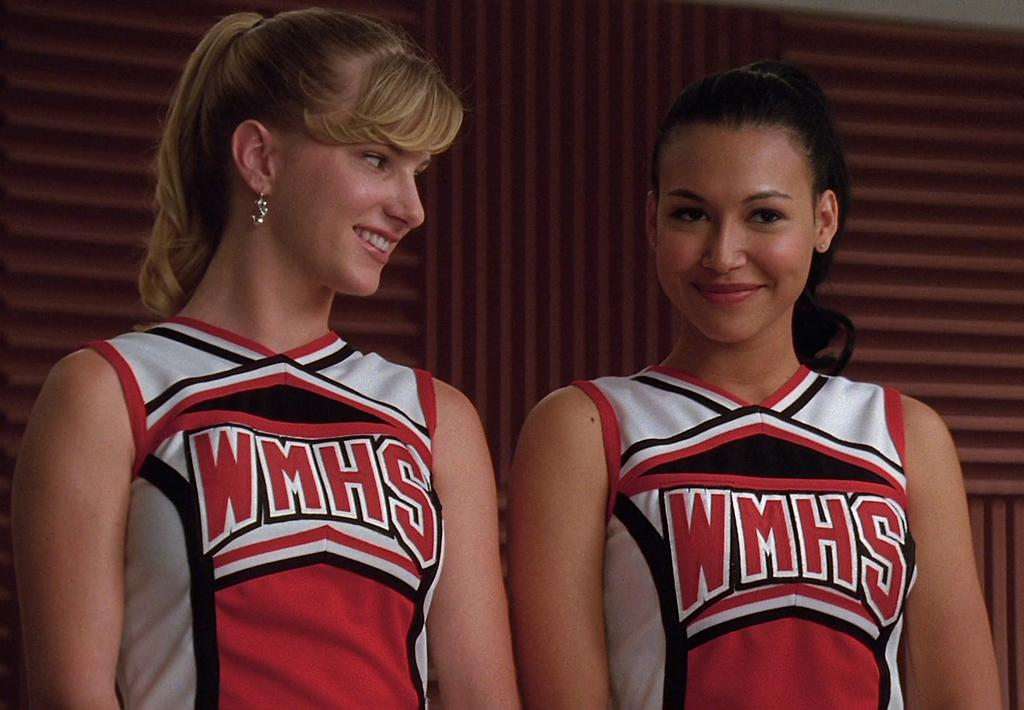Who is present in the image? There are women in the image. What expression do the women have? The women are smiling. What can be seen in the background of the image? There is a wall in the background of the image. What type of tomatoes can be heard in the image? There are no tomatoes present in the image, and therefore no sounds can be heard from them. 